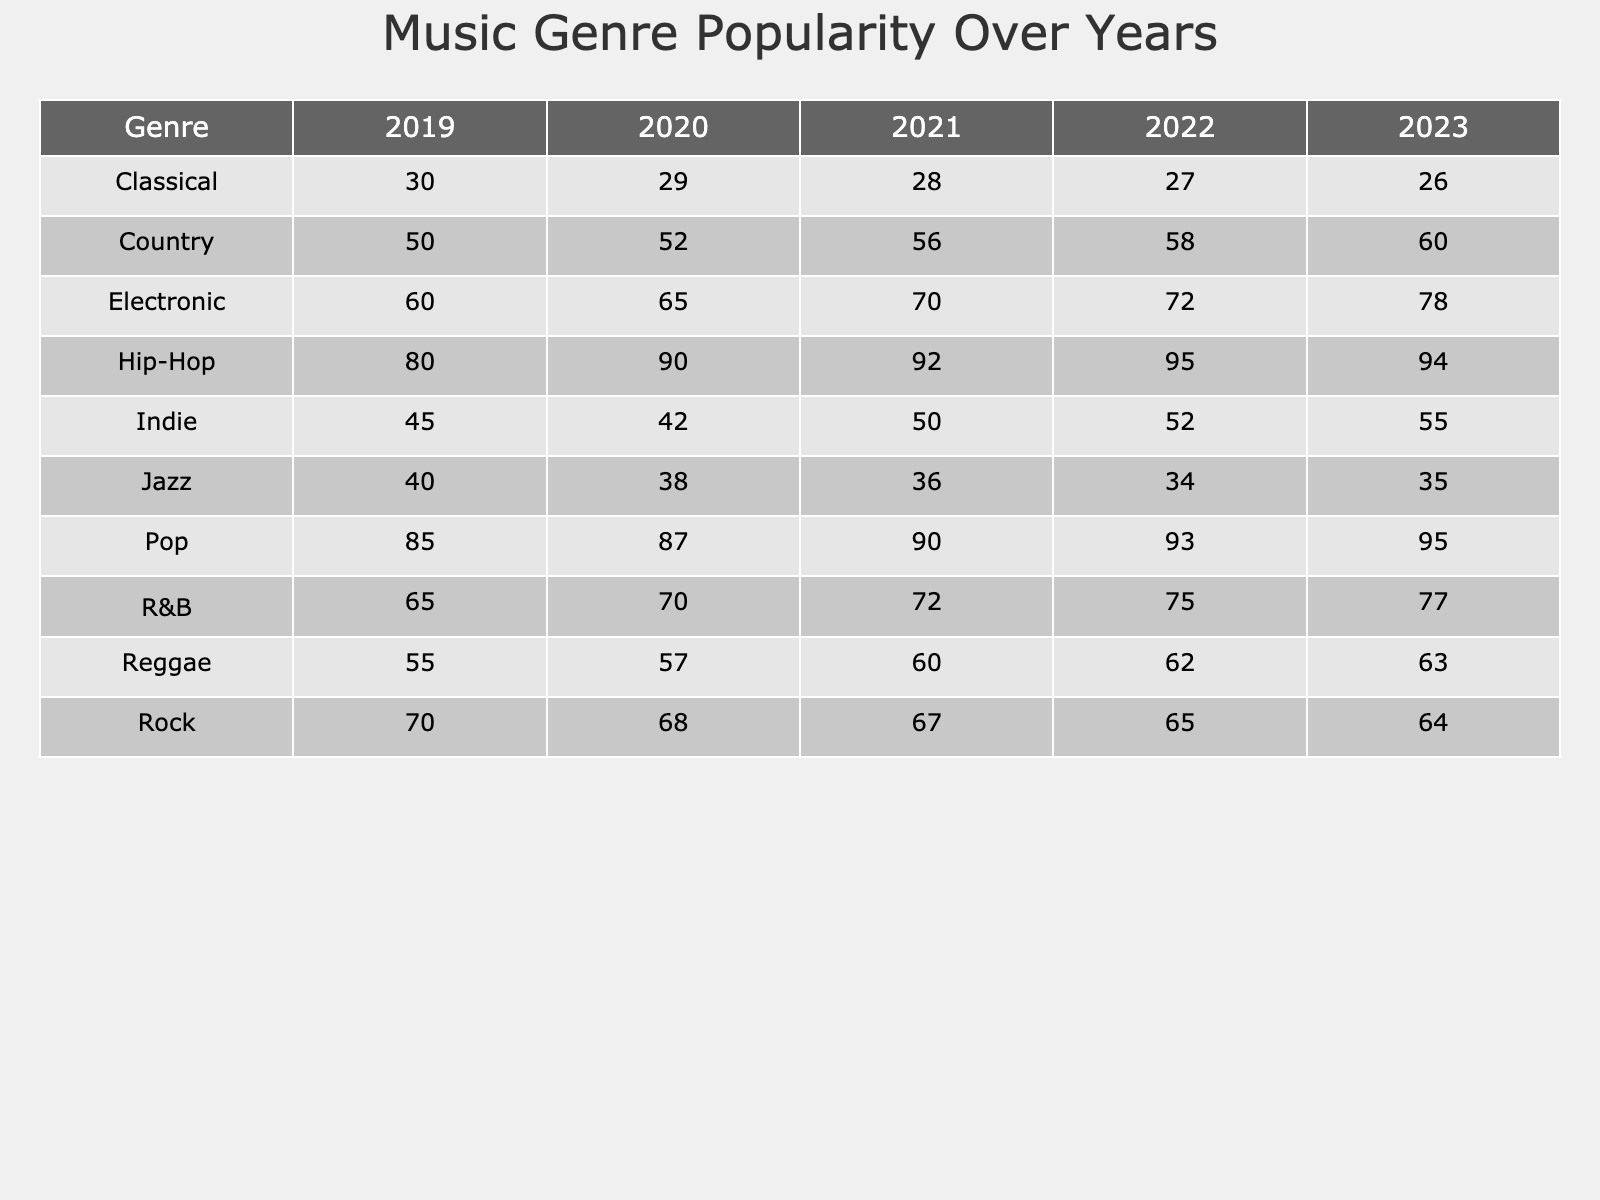What was the popularity score of Hip-Hop in 2022? The table shows that the popularity score of Hip-Hop for the year 2022 is listed directly under that year, which is 95.
Answer: 95 Which genre had the lowest popularity score in 2020? By examining the table for the year 2020, the lowest popularity score is for the Classical genre, which is 29.
Answer: Classical What is the average popularity score of Pop across all five years? Looking at the Pop scores: 85, 87, 90, 93, 95. We sum these values (85 + 87 + 90 + 93 + 95 = 450) and divide by 5 to find the average (450 / 5 = 90).
Answer: 90 Did Electronic ever have a popularity score lower than 60? By checking the table, I can see the Electronic score for 2019 is 60, so it did not drop below 60 in any year.
Answer: No What was the change in the popularity score of Rock from 2019 to 2023? The score for Rock in 2019 is 70, and in 2023 it's 64. Therefore, the change is calculated by subtracting 64 from 70, resulting in a decrease of 6.
Answer: 6 Which genre consistently showed an increase in popularity over the years? Examining the scores year-by-year, I see that Pop and Hip-Hop both increased every year. Pop went from 85 to 95, and Hip-Hop from 80 to 94. This confirms that these two genres consistently showed an increase.
Answer: Pop and Hip-Hop What was the median popularity score of Indie for the years provided? The Indie scores across the years are 45, 42, 50, 52, and 55. When ordered, they are: 42, 45, 50, 52, 55. The median, being the middle value in this ordered list, is 50.
Answer: 50 Which genre had the highest popularity score in 2023, and what was its score? In 2023, the highest score is found by comparing all genres; Pop has the highest score of 95 for that year.
Answer: Pop, 95 How much did the R&B popularity score increase from 2019 to 2023? The R&B score in 2019 is 65 and in 2023 it is 77. The increase is calculated by subtracting 65 from 77, resulting in an increase of 12.
Answer: 12 Which genre had a popularity score of 60 or above in 2021? By looking through the 2021 scores, I note that R&B (72), Pop (90), Hip-Hop (92), and Electronic (70) all have scores of 60 or above.
Answer: R&B, Pop, Hip-Hop, Electronic What is the overall trend for Country music over the years? Observing the Country scores: 50 (2019), 52 (2020), 56 (2021), 58 (2022), 60 (2023), it's clear there is a consistent upward trend in popularity each year.
Answer: Increasing trend 